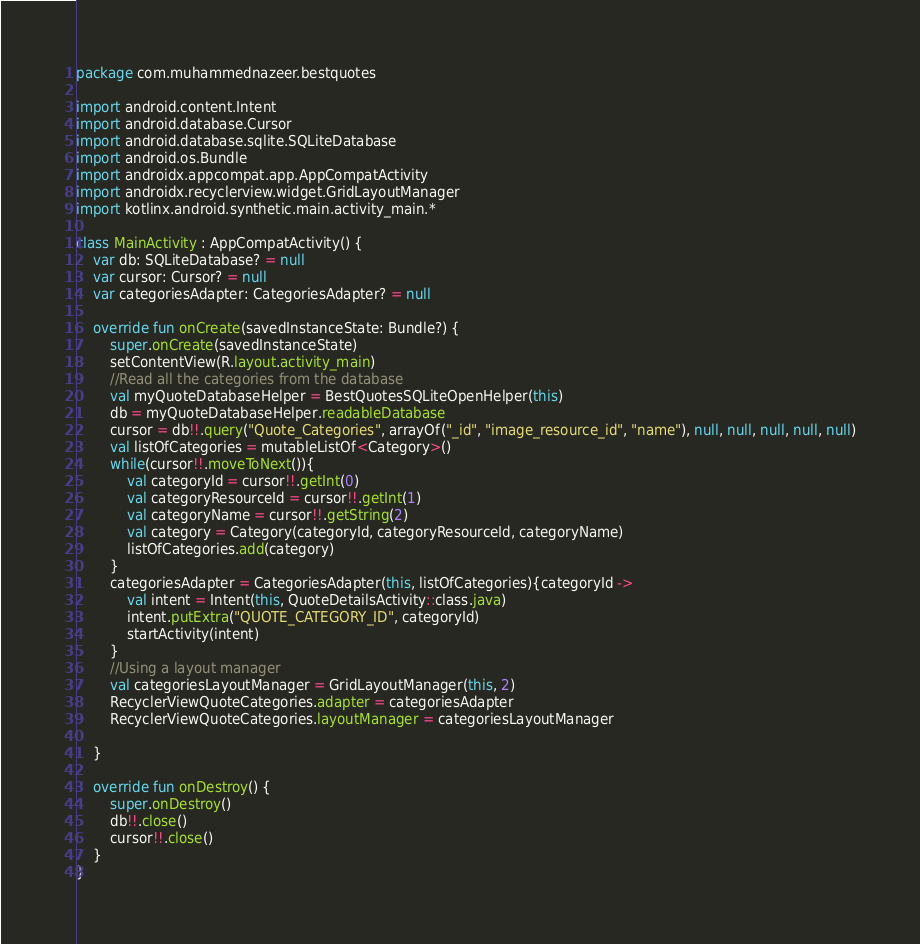<code> <loc_0><loc_0><loc_500><loc_500><_Kotlin_>package com.muhammednazeer.bestquotes

import android.content.Intent
import android.database.Cursor
import android.database.sqlite.SQLiteDatabase
import android.os.Bundle
import androidx.appcompat.app.AppCompatActivity
import androidx.recyclerview.widget.GridLayoutManager
import kotlinx.android.synthetic.main.activity_main.*

class MainActivity : AppCompatActivity() {
    var db: SQLiteDatabase? = null
    var cursor: Cursor? = null
    var categoriesAdapter: CategoriesAdapter? = null

    override fun onCreate(savedInstanceState: Bundle?) {
        super.onCreate(savedInstanceState)
        setContentView(R.layout.activity_main)
        //Read all the categories from the database
        val myQuoteDatabaseHelper = BestQuotesSQLiteOpenHelper(this)
        db = myQuoteDatabaseHelper.readableDatabase
        cursor = db!!.query("Quote_Categories", arrayOf("_id", "image_resource_id", "name"), null, null, null, null, null)
        val listOfCategories = mutableListOf<Category>()
        while(cursor!!.moveToNext()){
            val categoryId = cursor!!.getInt(0)
            val categoryResourceId = cursor!!.getInt(1)
            val categoryName = cursor!!.getString(2)
            val category = Category(categoryId, categoryResourceId, categoryName)
            listOfCategories.add(category)
        }
        categoriesAdapter = CategoriesAdapter(this, listOfCategories){categoryId ->
            val intent = Intent(this, QuoteDetailsActivity::class.java)
            intent.putExtra("QUOTE_CATEGORY_ID", categoryId)
            startActivity(intent)
        }
        //Using a layout manager
        val categoriesLayoutManager = GridLayoutManager(this, 2)
        RecyclerViewQuoteCategories.adapter = categoriesAdapter
        RecyclerViewQuoteCategories.layoutManager = categoriesLayoutManager

    }

    override fun onDestroy() {
        super.onDestroy()
        db!!.close()
        cursor!!.close()
    }
}
</code> 